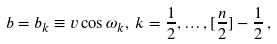Convert formula to latex. <formula><loc_0><loc_0><loc_500><loc_500>b = b _ { k } \equiv v \cos \omega _ { k } , \, k = { \frac { 1 } { 2 } , \dots , [ \frac { n } { 2 } ] - \frac { 1 } { 2 } } \, ,</formula> 